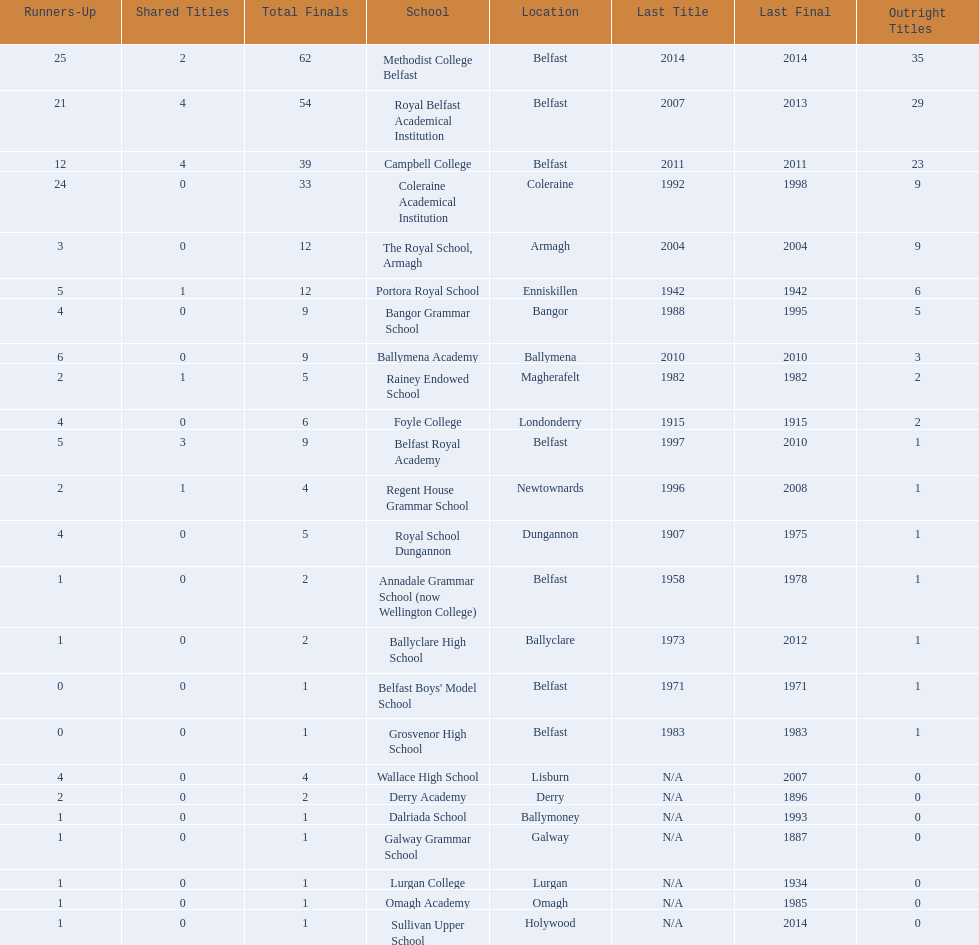Who has the most recent title win, campbell college or regent house grammar school? Campbell College. 